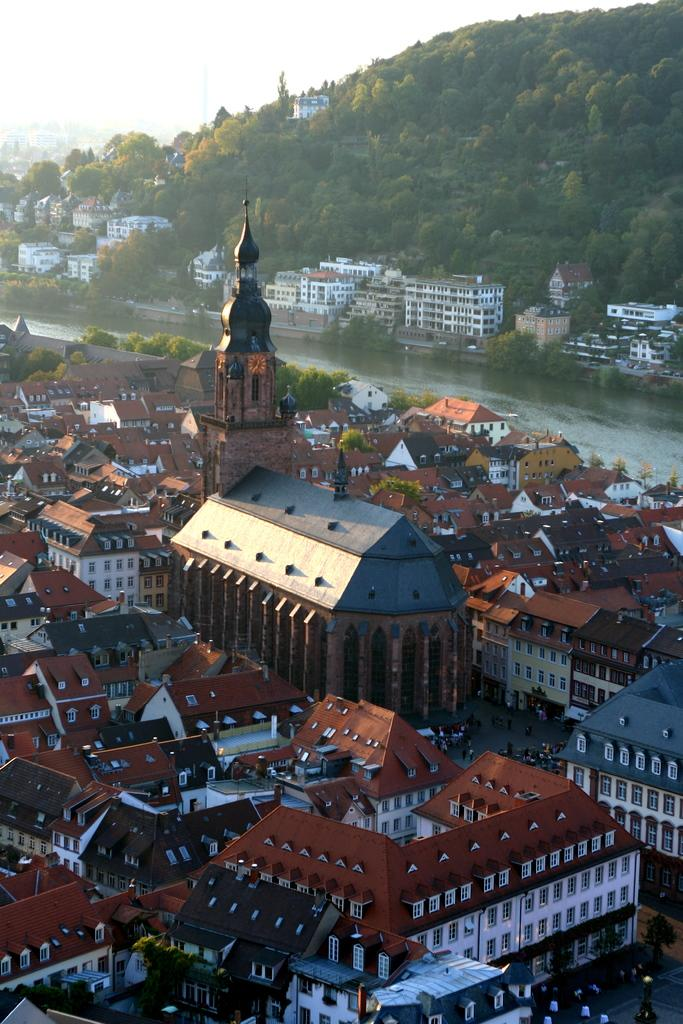What type of water feature is present in the image? There is a canal in the image. How is the canal situated in relation to the buildings? The canal is between buildings. What geographical feature can be seen in the top right of the image? There is a hill in the top right of the image. What is visible at the top of the image? The sky is visible at the top of the image. What type of furniture can be seen floating in the canal in the image? There is no furniture present in the image, and nothing is floating in the canal. 